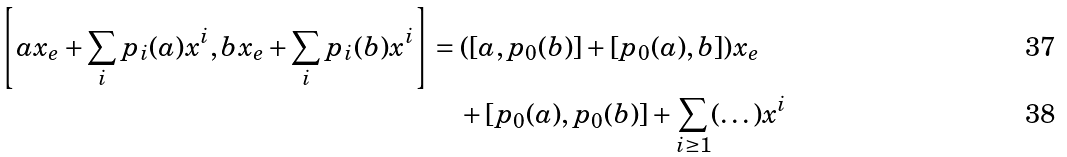Convert formula to latex. <formula><loc_0><loc_0><loc_500><loc_500>\left [ a x _ { e } + \sum _ { i } p _ { i } ( a ) x ^ { i } , b x _ { e } + \sum _ { i } p _ { i } ( b ) x ^ { i } \right ] & = ( [ a , p _ { 0 } ( b ) ] + [ p _ { 0 } ( a ) , b ] ) x _ { e } \\ & \quad + [ p _ { 0 } ( a ) , p _ { 0 } ( b ) ] + \sum _ { i \geq 1 } ( \dots ) x ^ { i }</formula> 